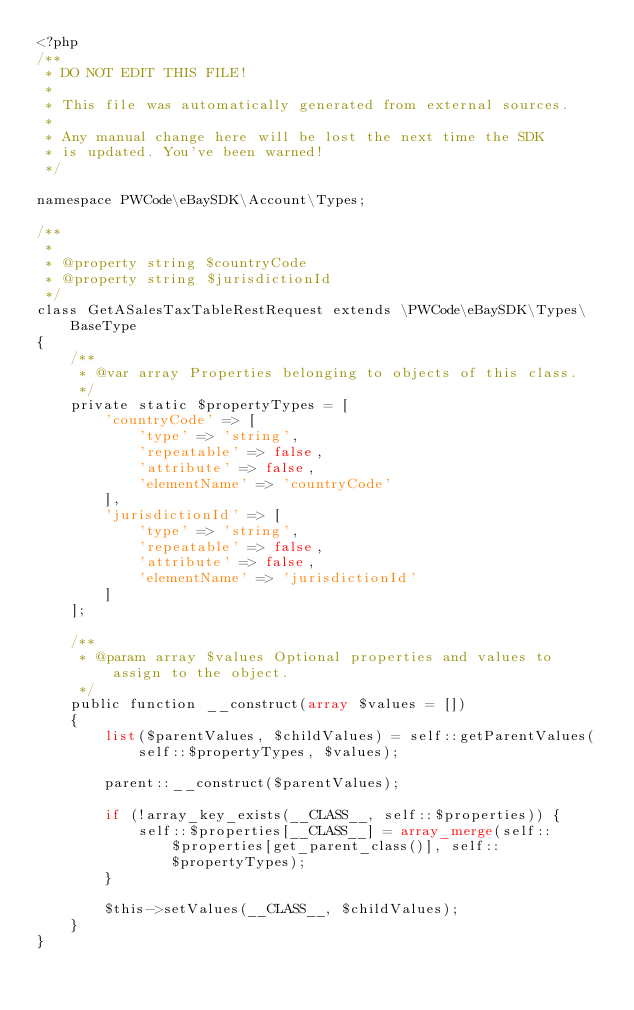Convert code to text. <code><loc_0><loc_0><loc_500><loc_500><_PHP_><?php
/**
 * DO NOT EDIT THIS FILE!
 *
 * This file was automatically generated from external sources.
 *
 * Any manual change here will be lost the next time the SDK
 * is updated. You've been warned!
 */

namespace PWCode\eBaySDK\Account\Types;

/**
 *
 * @property string $countryCode
 * @property string $jurisdictionId
 */
class GetASalesTaxTableRestRequest extends \PWCode\eBaySDK\Types\BaseType
{
    /**
     * @var array Properties belonging to objects of this class.
     */
    private static $propertyTypes = [
        'countryCode' => [
            'type' => 'string',
            'repeatable' => false,
            'attribute' => false,
            'elementName' => 'countryCode'
        ],
        'jurisdictionId' => [
            'type' => 'string',
            'repeatable' => false,
            'attribute' => false,
            'elementName' => 'jurisdictionId'
        ]
    ];

    /**
     * @param array $values Optional properties and values to assign to the object.
     */
    public function __construct(array $values = [])
    {
        list($parentValues, $childValues) = self::getParentValues(self::$propertyTypes, $values);

        parent::__construct($parentValues);

        if (!array_key_exists(__CLASS__, self::$properties)) {
            self::$properties[__CLASS__] = array_merge(self::$properties[get_parent_class()], self::$propertyTypes);
        }

        $this->setValues(__CLASS__, $childValues);
    }
}
</code> 